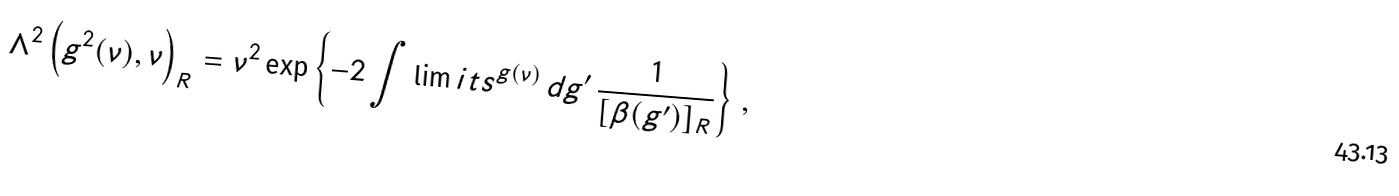Convert formula to latex. <formula><loc_0><loc_0><loc_500><loc_500>\Lambda ^ { 2 } \left ( g ^ { 2 } ( \nu ) , \nu \right ) _ { R } = \nu ^ { 2 } \exp \left \{ - 2 \int \lim i t s ^ { g ( \nu ) } \, d g ^ { \prime } \, \frac { 1 } { [ \beta ( g ^ { \prime } ) ] _ { R } } \right \} \, ,</formula> 